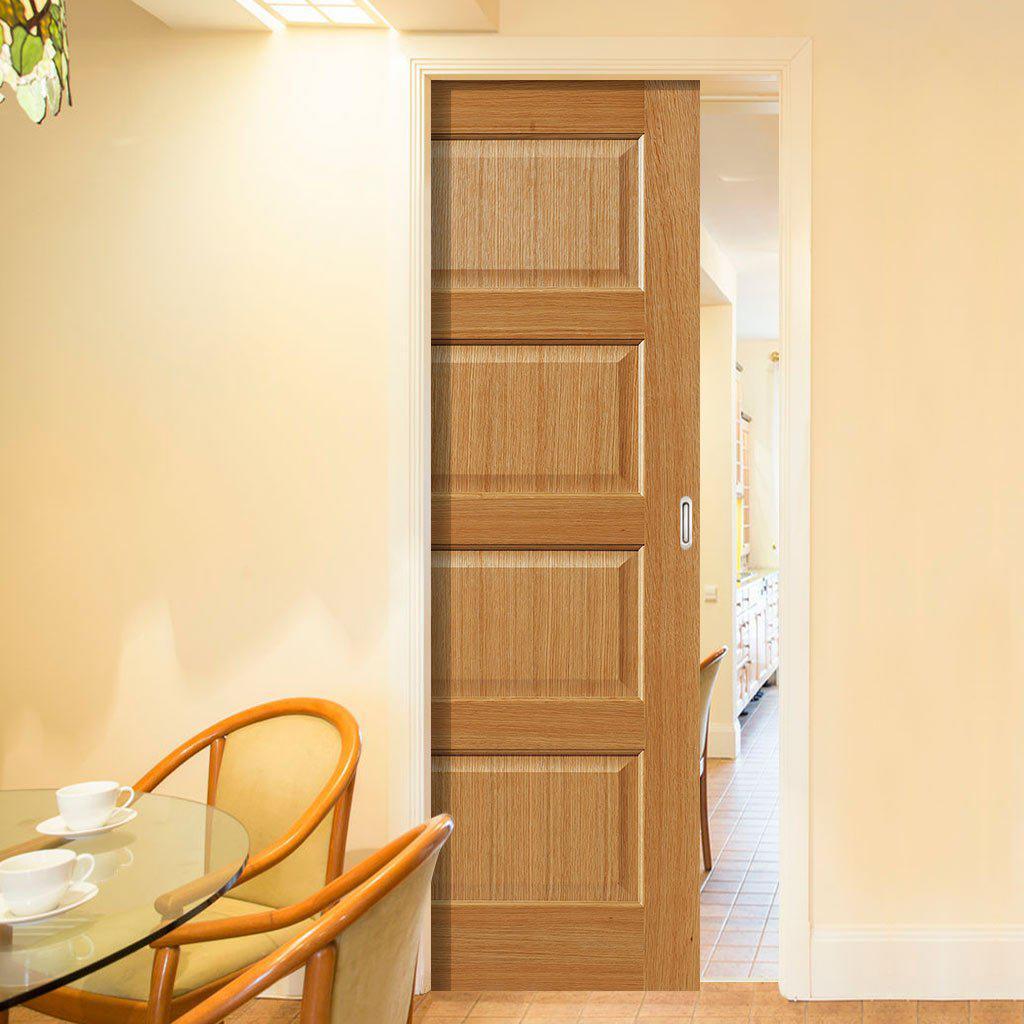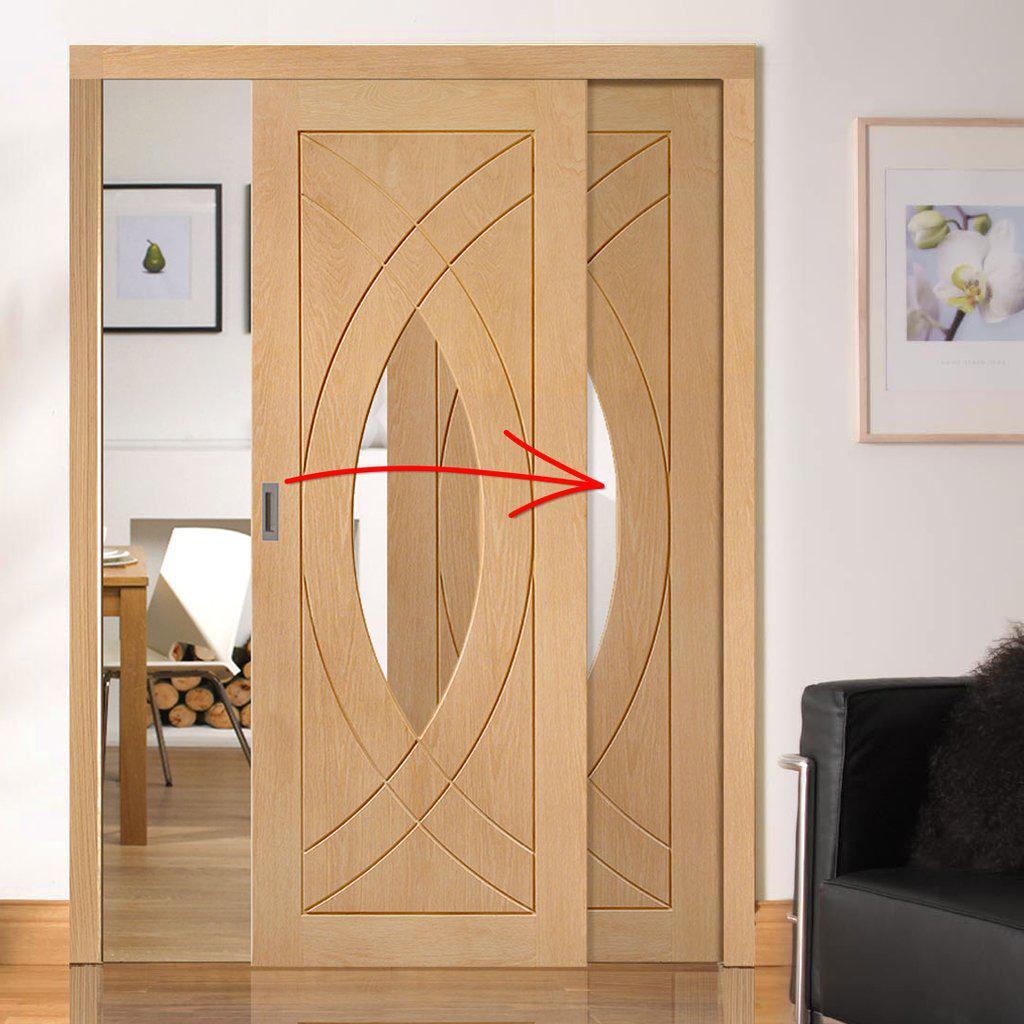The first image is the image on the left, the second image is the image on the right. Assess this claim about the two images: "One image shows wooden sliding doors with overlapping semi-circle designs on them.". Correct or not? Answer yes or no. Yes. The first image is the image on the left, the second image is the image on the right. Examine the images to the left and right. Is the description "There are two chairs in the image on the left." accurate? Answer yes or no. Yes. 